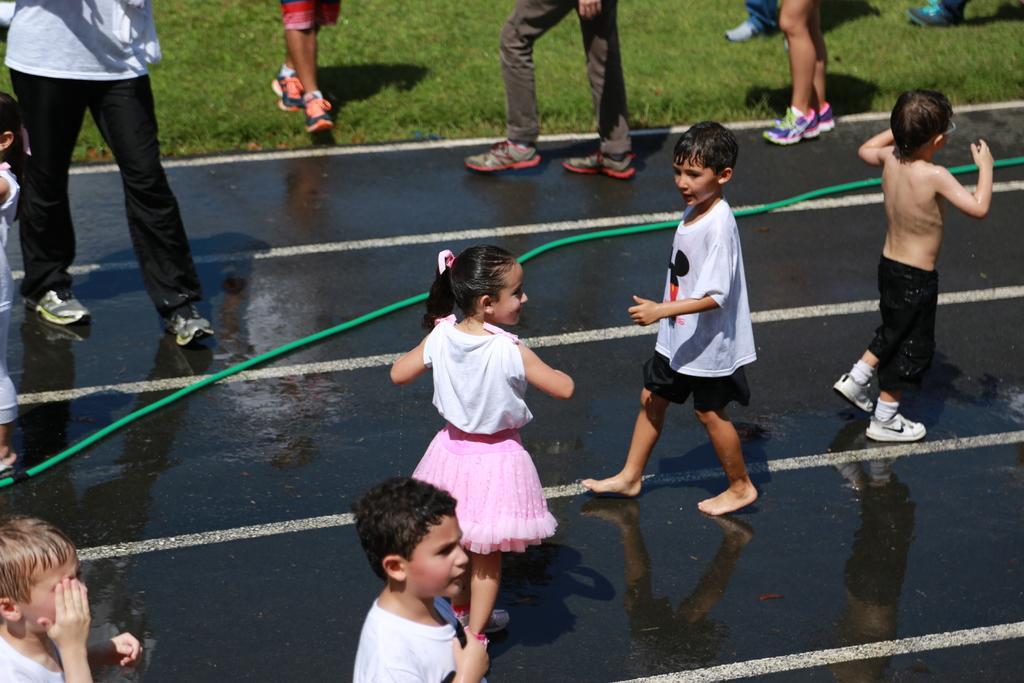In one or two sentences, can you explain what this image depicts? In this picture I can see few people are standing and I can see few boys and a girl and I can see grass on the ground and a water pipe. 